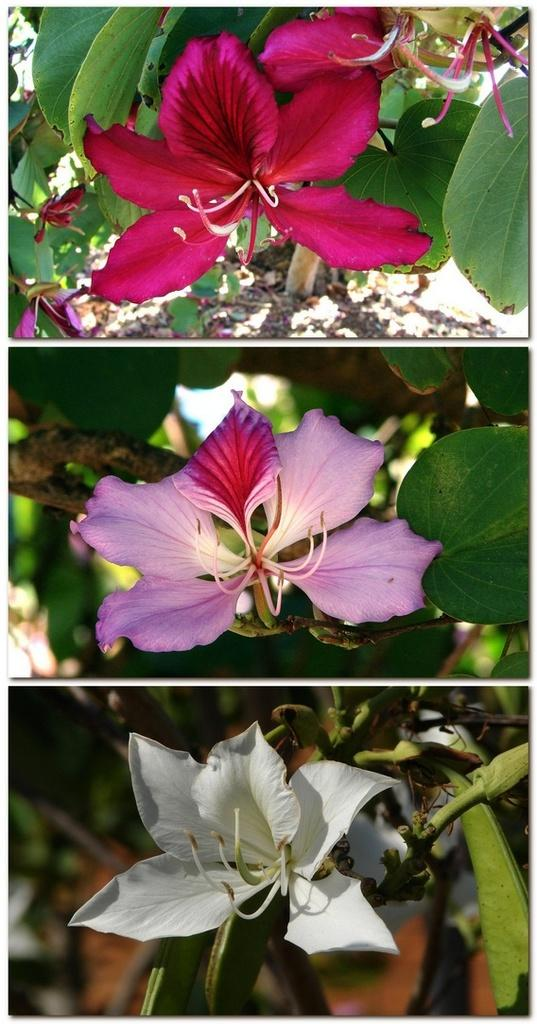What type of artwork is shown in the image? The image is a collage. How many images are included in the collage? There are three images in the collage. What is the common subject in each image? Each image contains flowers. What can be observed about the colors of the flowers? The flowers have different colors. Where are the flowers located in the images? The flowers are on a plant. What plot of land is visible in the image? There is no plot of land visible in the image; it is a collage of images featuring flowers on a plant. What type of boot is shown in the image? There is no boot present in the image. 